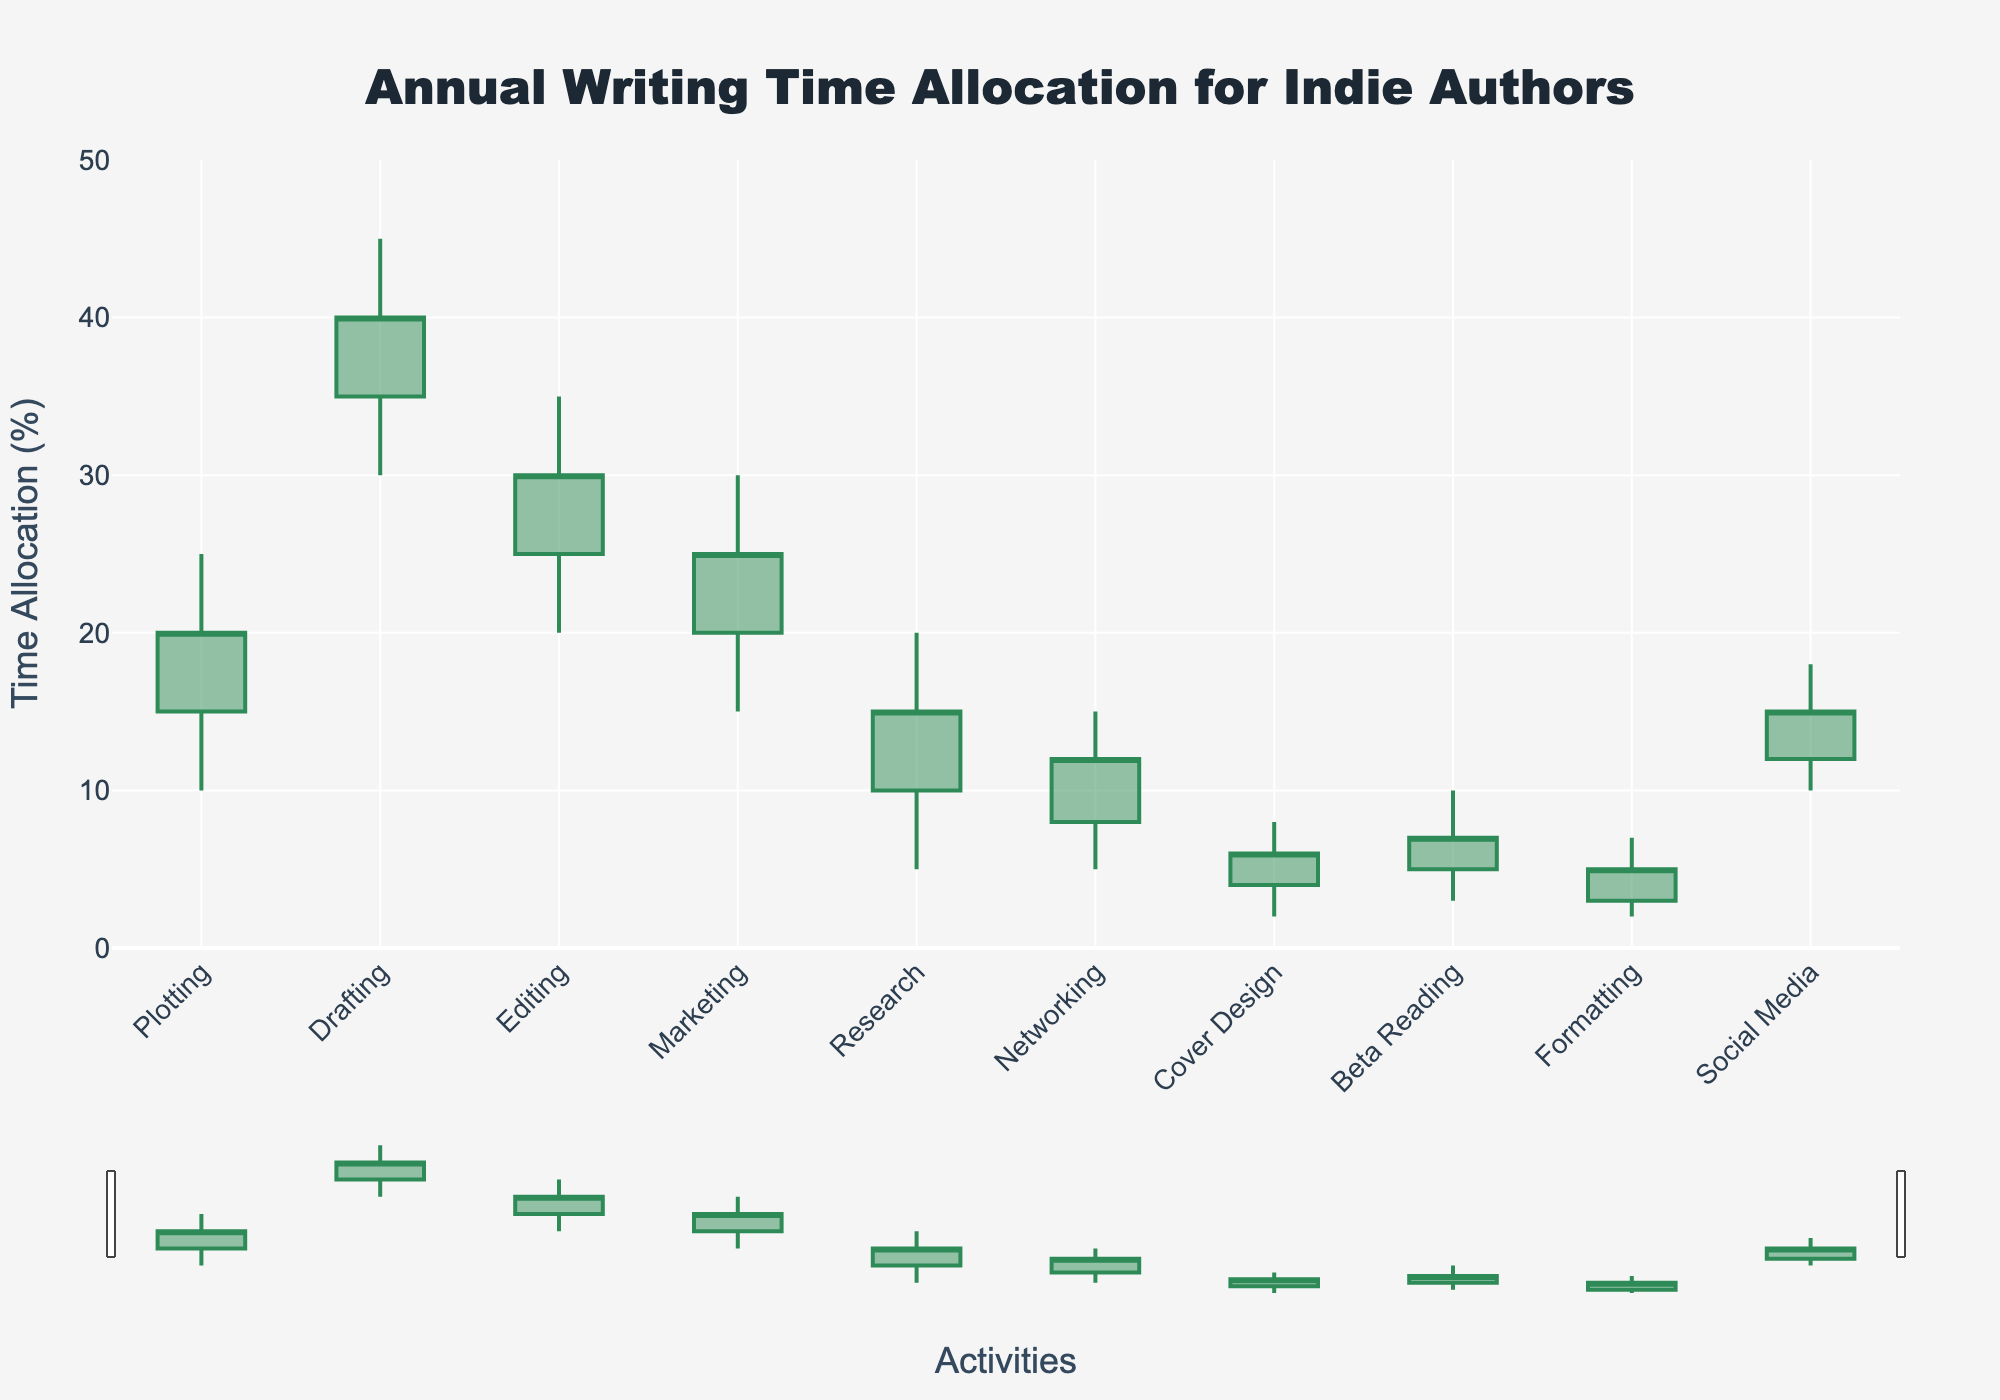What is the title of the figure? The title of the figure is provided at the top and centered. It states, "Annual Writing Time Allocation for Indie Authors."
Answer: Annual Writing Time Allocation for Indie Authors How many activities are listed in the figure? Look at the x-axis where the activities are labeled. Count the distinct labels.
Answer: 10 Which activity has the highest upper bound (High) of time allocation? Identify the activity with the tallest candlestick top (highest High value). "Drafting" goes up to 45.
Answer: Drafting What is the time percentage range for "Cover Design"? For "Cover Design", the range is determined by the Low and High values. Low is 2 and High is 8, resulting in a range of 8 - 2 = 6.
Answer: 6 What's the difference between the High and Low values for "Editing"? Identify the High and Low values for "Editing" which are 35 and 20 respectively. The difference is 35 - 20 = 15.
Answer: 15 Which activity has the smallest opening value (Open) and what is it? The opening value is the second column in each candlestick. "Formatting" has the smallest open value of 3.
Answer: Formatting, 3 Between "Marketing" and "Social Media," which one has a higher closing value (Close)? Compare the closing values for these two activities. "Marketing" has a Close of 25 and "Social Media" has a Close of 15.
Answer: Marketing What is the median closing value among all activities? Arrange the closing values in ascending order (5, 6, 7, 12, 15, 15, 20, 25, 25, 30). The median is the average of the 5th and 6th values, which is (15 + 15) / 2 = 15.
Answer: 15 Which two activities have the same high value and what is this value? Look at the high values for all activities. Both "Plotting" and "Editing" have a high value of 35.
Answer: Plotting and Editing, 35 What is the average time allocated for "Research"? Add the four values (Low, Open, Close, High) for "Research" and divide by 4. (5 + 10 + 15 + 20)/4 = 12.5.
Answer: 12.5 